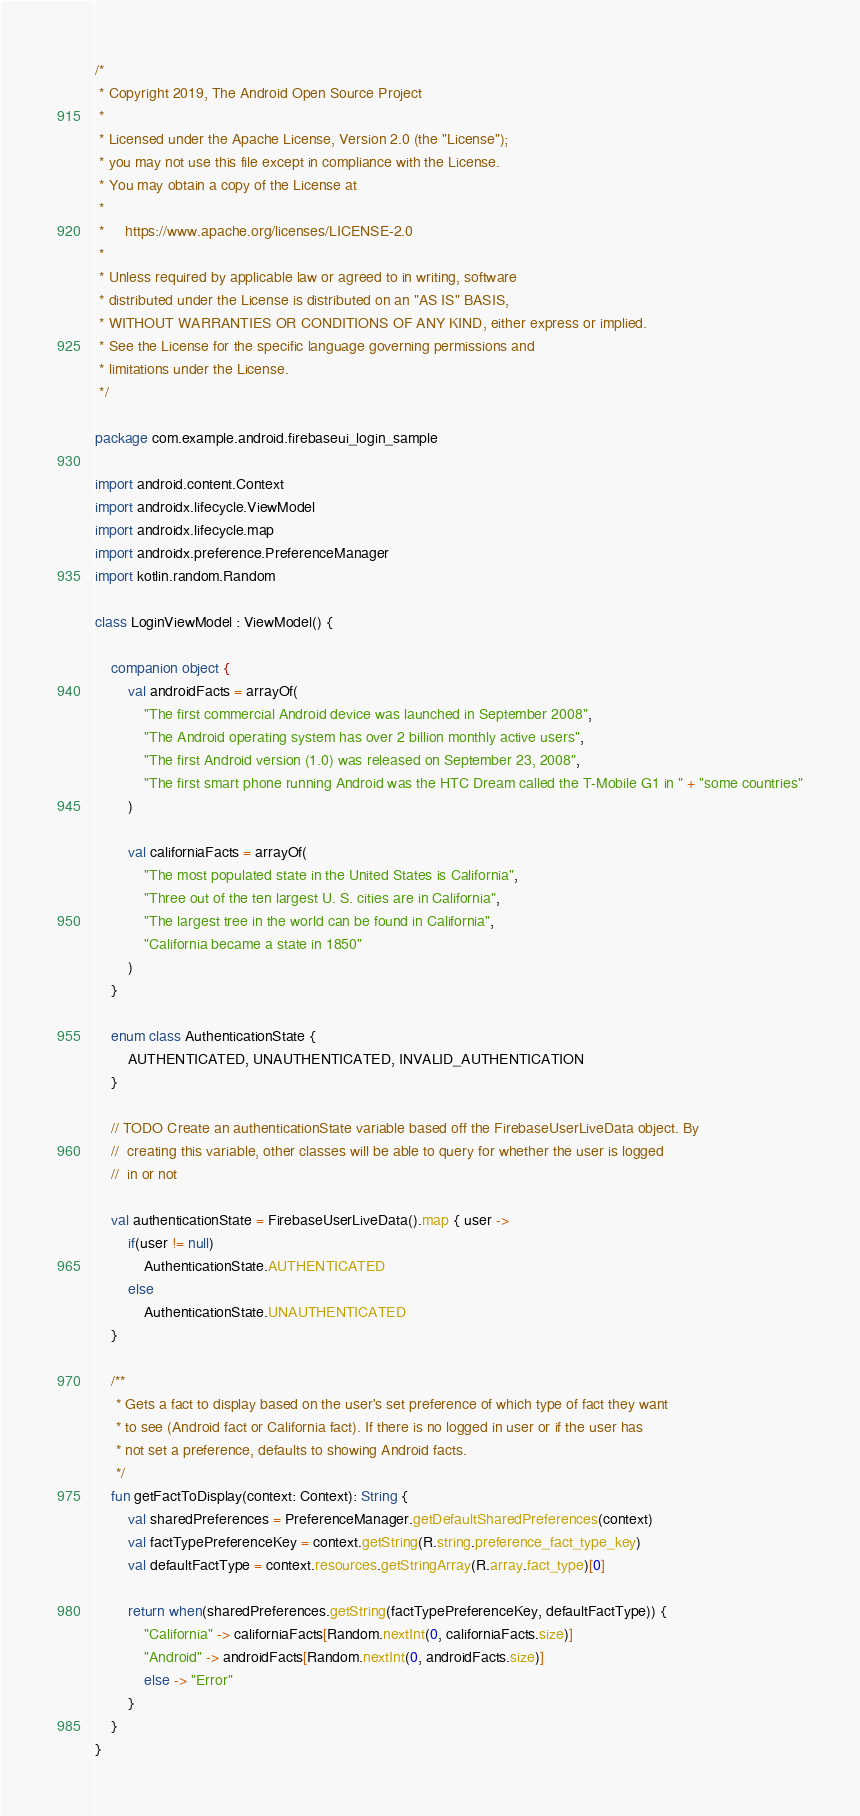<code> <loc_0><loc_0><loc_500><loc_500><_Kotlin_>/*
 * Copyright 2019, The Android Open Source Project
 *
 * Licensed under the Apache License, Version 2.0 (the "License");
 * you may not use this file except in compliance with the License.
 * You may obtain a copy of the License at
 *
 *     https://www.apache.org/licenses/LICENSE-2.0
 *
 * Unless required by applicable law or agreed to in writing, software
 * distributed under the License is distributed on an "AS IS" BASIS,
 * WITHOUT WARRANTIES OR CONDITIONS OF ANY KIND, either express or implied.
 * See the License for the specific language governing permissions and
 * limitations under the License.
 */

package com.example.android.firebaseui_login_sample

import android.content.Context
import androidx.lifecycle.ViewModel
import androidx.lifecycle.map
import androidx.preference.PreferenceManager
import kotlin.random.Random

class LoginViewModel : ViewModel() {

    companion object {
        val androidFacts = arrayOf(
            "The first commercial Android device was launched in September 2008",
            "The Android operating system has over 2 billion monthly active users",
            "The first Android version (1.0) was released on September 23, 2008",
            "The first smart phone running Android was the HTC Dream called the T-Mobile G1 in " + "some countries"
        )

        val californiaFacts = arrayOf(
            "The most populated state in the United States is California",
            "Three out of the ten largest U. S. cities are in California",
            "The largest tree in the world can be found in California",
            "California became a state in 1850"
        )
    }

    enum class AuthenticationState {
        AUTHENTICATED, UNAUTHENTICATED, INVALID_AUTHENTICATION
    }

    // TODO Create an authenticationState variable based off the FirebaseUserLiveData object. By
    //  creating this variable, other classes will be able to query for whether the user is logged
    //  in or not

    val authenticationState = FirebaseUserLiveData().map { user ->
        if(user != null)
            AuthenticationState.AUTHENTICATED
        else
            AuthenticationState.UNAUTHENTICATED
    }

    /**
     * Gets a fact to display based on the user's set preference of which type of fact they want
     * to see (Android fact or California fact). If there is no logged in user or if the user has
     * not set a preference, defaults to showing Android facts.
     */
    fun getFactToDisplay(context: Context): String {
        val sharedPreferences = PreferenceManager.getDefaultSharedPreferences(context)
        val factTypePreferenceKey = context.getString(R.string.preference_fact_type_key)
        val defaultFactType = context.resources.getStringArray(R.array.fact_type)[0]

        return when(sharedPreferences.getString(factTypePreferenceKey, defaultFactType)) {
            "California" -> californiaFacts[Random.nextInt(0, californiaFacts.size)]
            "Android" -> androidFacts[Random.nextInt(0, androidFacts.size)]
            else -> "Error"
        }
    }
}
</code> 